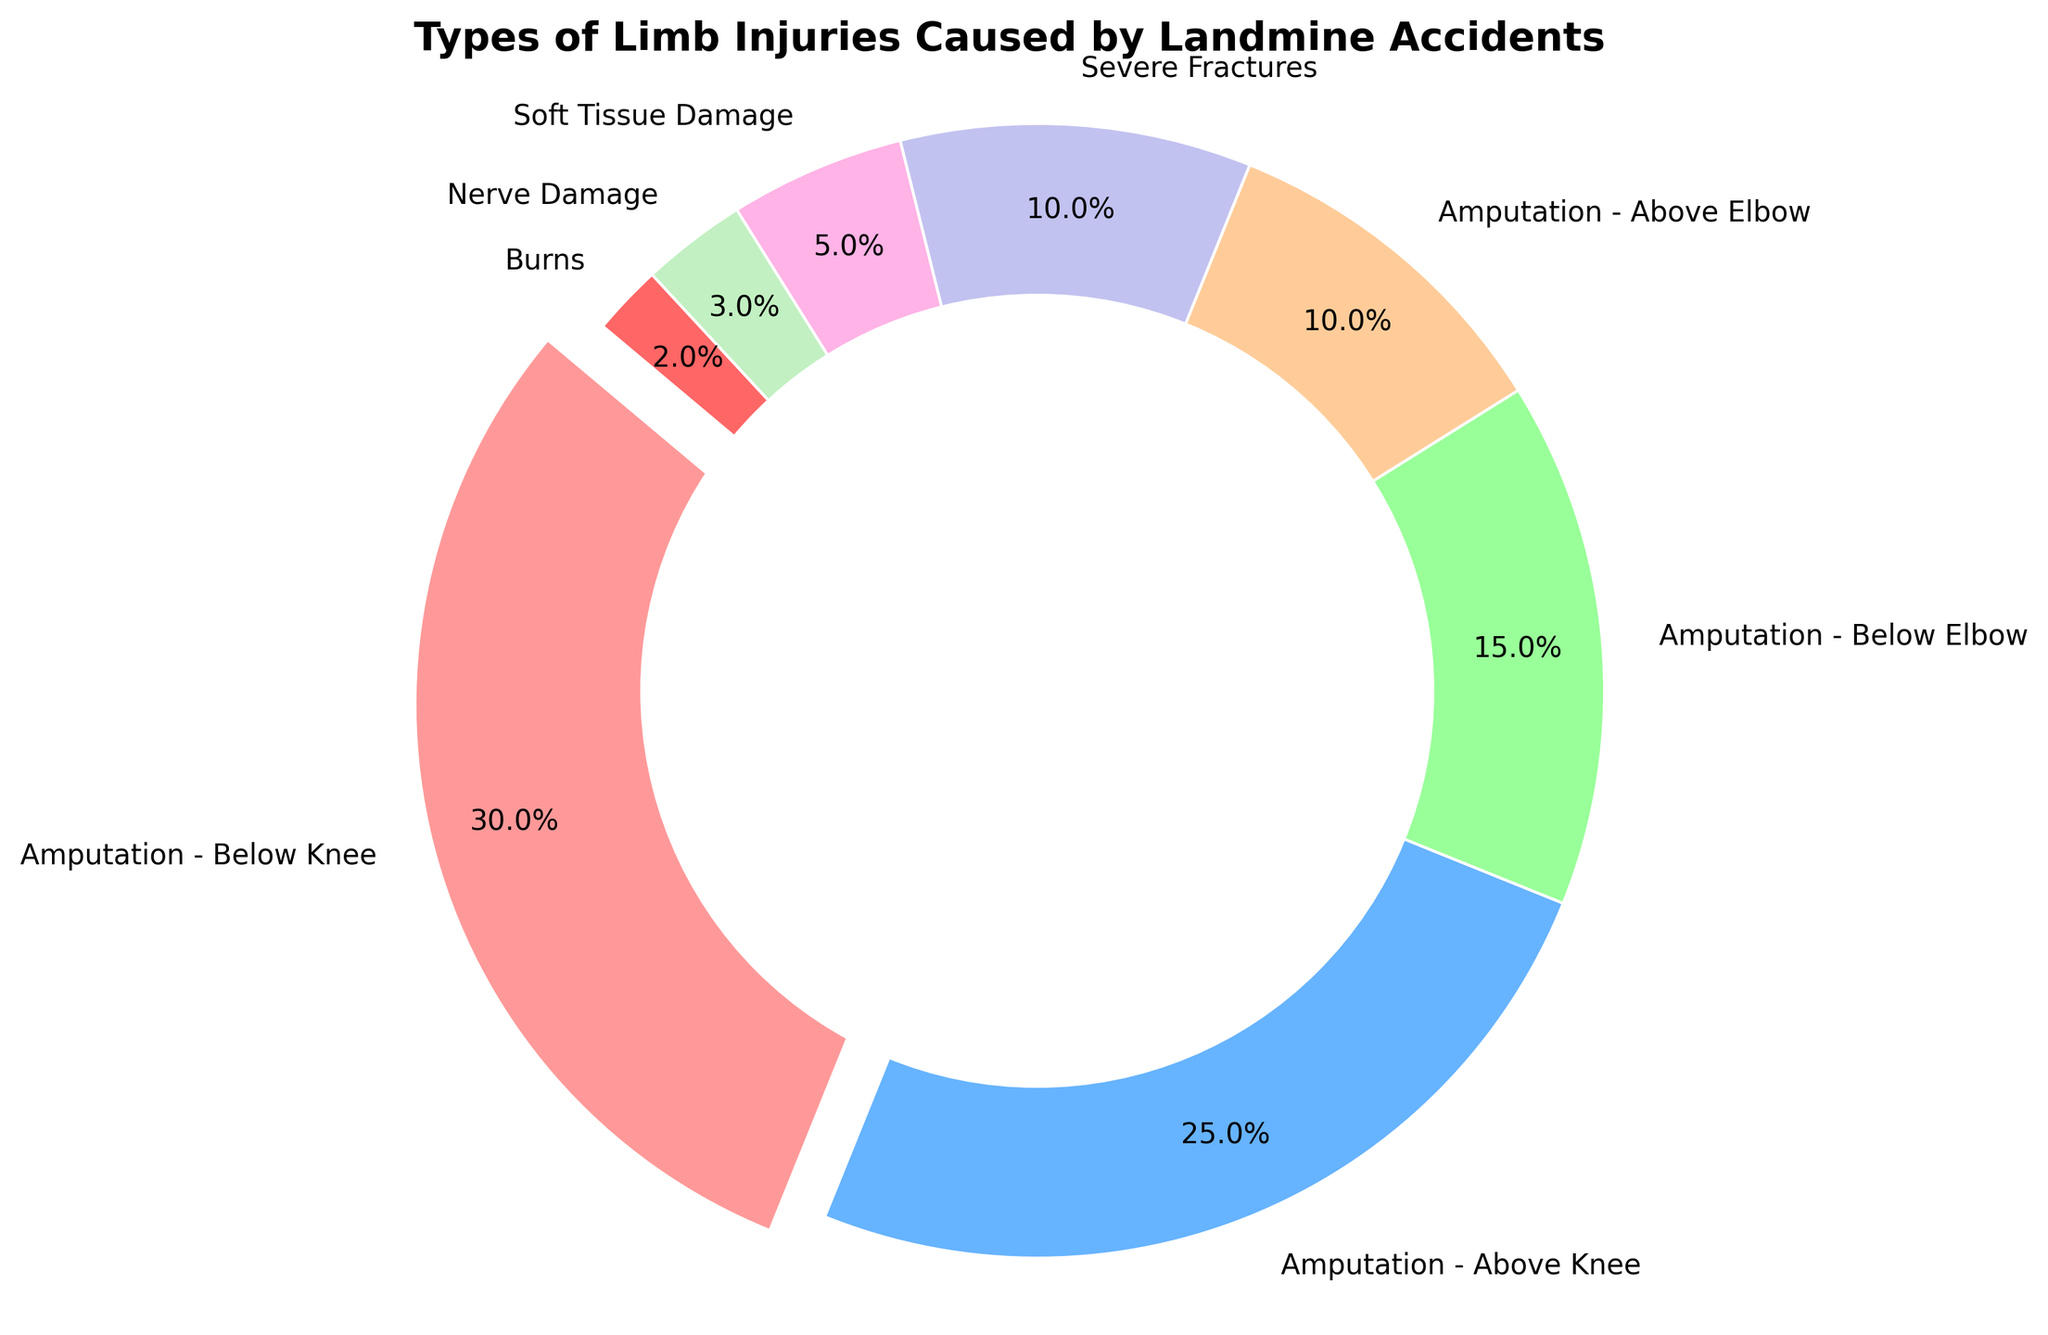what type of limb injury is represented with the largest section in the chart? The largest section is represented by the part of the chart that has the largest wedge. By looking at the visual size of the wedges, Amputation - Below Knee has the largest section.
Answer: Amputation - Below Knee Which injuries collectively make up 50% of all limb injuries caused by landmine accidents? To find this, identify the wedges representing injuries and their percentages and sum them until reaching 50%. Amputation - Below Knee (30%) + Amputation - Above Knee (25%) = 55%. Since 55% is greater than 50%, the largest two categories already surpass 50%.
Answer: Amputation - Below Knee and Amputation - Above Knee What is the combined percentage of severe fractures and soft tissue damage? Add the percentages of severe fractures and soft tissue damage: Severe Fractures (10%) + Soft Tissue Damage (5%) = 15%.
Answer: 15% What type of injury is the smallest portion and what is its percentage? The smallest portion is indicated by the smallest wedge in the chart, which is Burns at 2%.
Answer: Burns, 2% Is there a greater percentage of below-knee or below-elbow amputations? By how much? Compare the wedges representing below-knee and below-elbow amputations: Below Knee is 30% and Below Elbow is 15%. The difference is calculated as 30% - 15% = 15%.
Answer: Below Knee, 15% What percentage of injuries are caused by types other than amputations? Sum the percentages of injuries other than the four types of amputations: Severe Fractures (10%) + Soft Tissue Damage (5%) + Nerve Damage (3%) + Burns (2%) = 20%.
Answer: 20% How much more common are above-knee amputations compared to above-elbow amputations? Compare the percentages of above-knee and above-elbow amputations: Above Knee (25%) and Above Elbow (10%). The difference is calculated as 25% - 10% = 15%.
Answer: 15% What color represents soft tissue damage in the chart and what is its percentage? The color representing soft tissue damage can be identified visually from the chart, which is the fifth color in the legend or chart wedges. Soft Tissue Damage is represented in pink and is 5%.
Answer: pink, 5% Is the percentage of nerve damage injuries less than half of the percentage of below-elbow amputations? Compare the percentages: Nerve Damage is 3%, which is less than half of Below Elbow Amputations (15%). Half of 15% is 7.5%, so 3% is indeed less than 7.5%.
Answer: Yes 